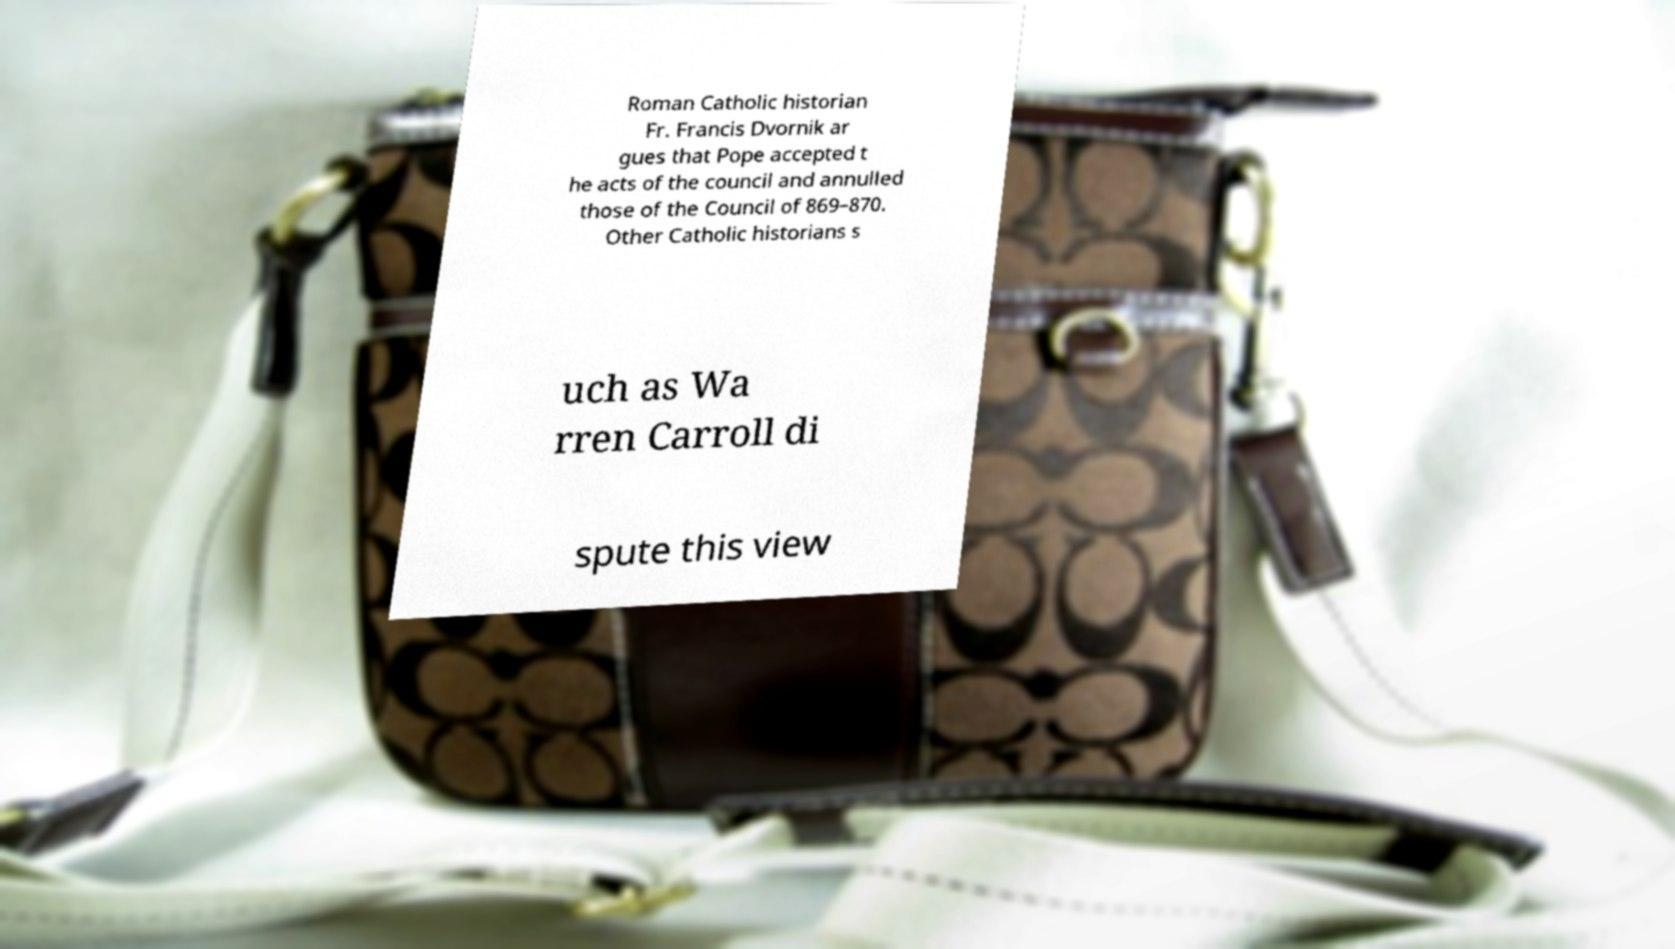For documentation purposes, I need the text within this image transcribed. Could you provide that? Roman Catholic historian Fr. Francis Dvornik ar gues that Pope accepted t he acts of the council and annulled those of the Council of 869–870. Other Catholic historians s uch as Wa rren Carroll di spute this view 